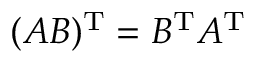<formula> <loc_0><loc_0><loc_500><loc_500>( A B ) ^ { T } = B ^ { T } A ^ { T }</formula> 